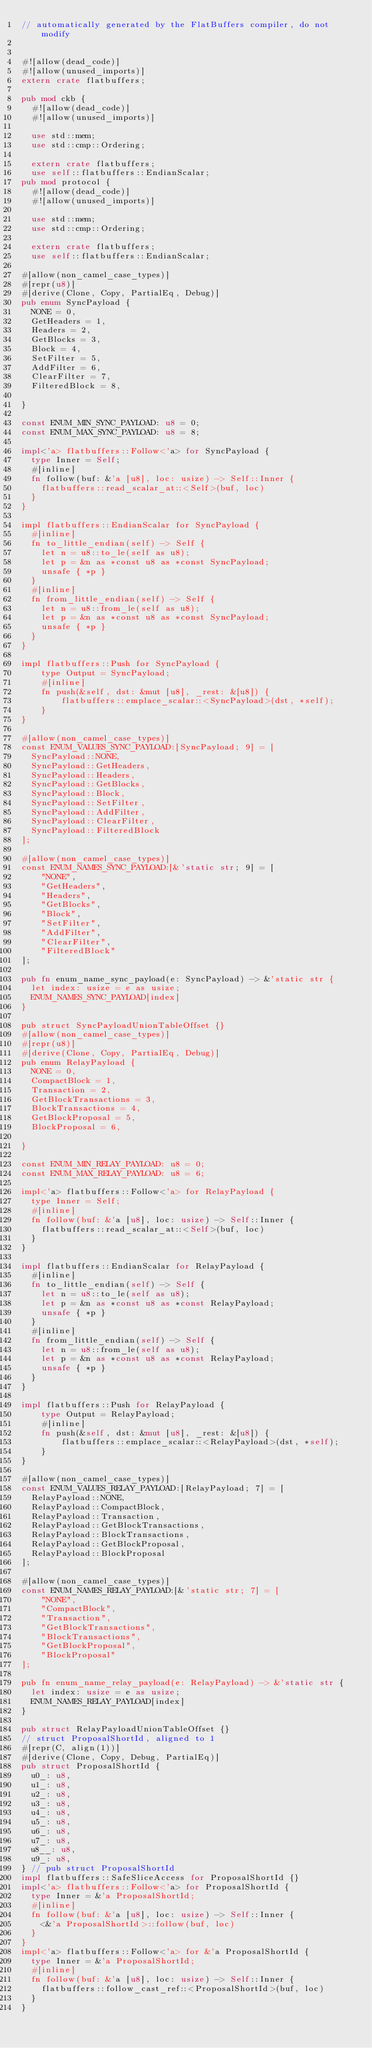Convert code to text. <code><loc_0><loc_0><loc_500><loc_500><_Rust_>// automatically generated by the FlatBuffers compiler, do not modify


#![allow(dead_code)]
#![allow(unused_imports)]
extern crate flatbuffers;

pub mod ckb {
  #![allow(dead_code)]
  #![allow(unused_imports)]

  use std::mem;
  use std::cmp::Ordering;

  extern crate flatbuffers;
  use self::flatbuffers::EndianScalar;
pub mod protocol {
  #![allow(dead_code)]
  #![allow(unused_imports)]

  use std::mem;
  use std::cmp::Ordering;

  extern crate flatbuffers;
  use self::flatbuffers::EndianScalar;

#[allow(non_camel_case_types)]
#[repr(u8)]
#[derive(Clone, Copy, PartialEq, Debug)]
pub enum SyncPayload {
  NONE = 0,
  GetHeaders = 1,
  Headers = 2,
  GetBlocks = 3,
  Block = 4,
  SetFilter = 5,
  AddFilter = 6,
  ClearFilter = 7,
  FilteredBlock = 8,

}

const ENUM_MIN_SYNC_PAYLOAD: u8 = 0;
const ENUM_MAX_SYNC_PAYLOAD: u8 = 8;

impl<'a> flatbuffers::Follow<'a> for SyncPayload {
  type Inner = Self;
  #[inline]
  fn follow(buf: &'a [u8], loc: usize) -> Self::Inner {
    flatbuffers::read_scalar_at::<Self>(buf, loc)
  }
}

impl flatbuffers::EndianScalar for SyncPayload {
  #[inline]
  fn to_little_endian(self) -> Self {
    let n = u8::to_le(self as u8);
    let p = &n as *const u8 as *const SyncPayload;
    unsafe { *p }
  }
  #[inline]
  fn from_little_endian(self) -> Self {
    let n = u8::from_le(self as u8);
    let p = &n as *const u8 as *const SyncPayload;
    unsafe { *p }
  }
}

impl flatbuffers::Push for SyncPayload {
    type Output = SyncPayload;
    #[inline]
    fn push(&self, dst: &mut [u8], _rest: &[u8]) {
        flatbuffers::emplace_scalar::<SyncPayload>(dst, *self);
    }
}

#[allow(non_camel_case_types)]
const ENUM_VALUES_SYNC_PAYLOAD:[SyncPayload; 9] = [
  SyncPayload::NONE,
  SyncPayload::GetHeaders,
  SyncPayload::Headers,
  SyncPayload::GetBlocks,
  SyncPayload::Block,
  SyncPayload::SetFilter,
  SyncPayload::AddFilter,
  SyncPayload::ClearFilter,
  SyncPayload::FilteredBlock
];

#[allow(non_camel_case_types)]
const ENUM_NAMES_SYNC_PAYLOAD:[&'static str; 9] = [
    "NONE",
    "GetHeaders",
    "Headers",
    "GetBlocks",
    "Block",
    "SetFilter",
    "AddFilter",
    "ClearFilter",
    "FilteredBlock"
];

pub fn enum_name_sync_payload(e: SyncPayload) -> &'static str {
  let index: usize = e as usize;
  ENUM_NAMES_SYNC_PAYLOAD[index]
}

pub struct SyncPayloadUnionTableOffset {}
#[allow(non_camel_case_types)]
#[repr(u8)]
#[derive(Clone, Copy, PartialEq, Debug)]
pub enum RelayPayload {
  NONE = 0,
  CompactBlock = 1,
  Transaction = 2,
  GetBlockTransactions = 3,
  BlockTransactions = 4,
  GetBlockProposal = 5,
  BlockProposal = 6,

}

const ENUM_MIN_RELAY_PAYLOAD: u8 = 0;
const ENUM_MAX_RELAY_PAYLOAD: u8 = 6;

impl<'a> flatbuffers::Follow<'a> for RelayPayload {
  type Inner = Self;
  #[inline]
  fn follow(buf: &'a [u8], loc: usize) -> Self::Inner {
    flatbuffers::read_scalar_at::<Self>(buf, loc)
  }
}

impl flatbuffers::EndianScalar for RelayPayload {
  #[inline]
  fn to_little_endian(self) -> Self {
    let n = u8::to_le(self as u8);
    let p = &n as *const u8 as *const RelayPayload;
    unsafe { *p }
  }
  #[inline]
  fn from_little_endian(self) -> Self {
    let n = u8::from_le(self as u8);
    let p = &n as *const u8 as *const RelayPayload;
    unsafe { *p }
  }
}

impl flatbuffers::Push for RelayPayload {
    type Output = RelayPayload;
    #[inline]
    fn push(&self, dst: &mut [u8], _rest: &[u8]) {
        flatbuffers::emplace_scalar::<RelayPayload>(dst, *self);
    }
}

#[allow(non_camel_case_types)]
const ENUM_VALUES_RELAY_PAYLOAD:[RelayPayload; 7] = [
  RelayPayload::NONE,
  RelayPayload::CompactBlock,
  RelayPayload::Transaction,
  RelayPayload::GetBlockTransactions,
  RelayPayload::BlockTransactions,
  RelayPayload::GetBlockProposal,
  RelayPayload::BlockProposal
];

#[allow(non_camel_case_types)]
const ENUM_NAMES_RELAY_PAYLOAD:[&'static str; 7] = [
    "NONE",
    "CompactBlock",
    "Transaction",
    "GetBlockTransactions",
    "BlockTransactions",
    "GetBlockProposal",
    "BlockProposal"
];

pub fn enum_name_relay_payload(e: RelayPayload) -> &'static str {
  let index: usize = e as usize;
  ENUM_NAMES_RELAY_PAYLOAD[index]
}

pub struct RelayPayloadUnionTableOffset {}
// struct ProposalShortId, aligned to 1
#[repr(C, align(1))]
#[derive(Clone, Copy, Debug, PartialEq)]
pub struct ProposalShortId {
  u0_: u8,
  u1_: u8,
  u2_: u8,
  u3_: u8,
  u4_: u8,
  u5_: u8,
  u6_: u8,
  u7_: u8,
  u8__: u8,
  u9_: u8,
} // pub struct ProposalShortId
impl flatbuffers::SafeSliceAccess for ProposalShortId {}
impl<'a> flatbuffers::Follow<'a> for ProposalShortId {
  type Inner = &'a ProposalShortId;
  #[inline]
  fn follow(buf: &'a [u8], loc: usize) -> Self::Inner {
    <&'a ProposalShortId>::follow(buf, loc)
  }
}
impl<'a> flatbuffers::Follow<'a> for &'a ProposalShortId {
  type Inner = &'a ProposalShortId;
  #[inline]
  fn follow(buf: &'a [u8], loc: usize) -> Self::Inner {
    flatbuffers::follow_cast_ref::<ProposalShortId>(buf, loc)
  }
}</code> 